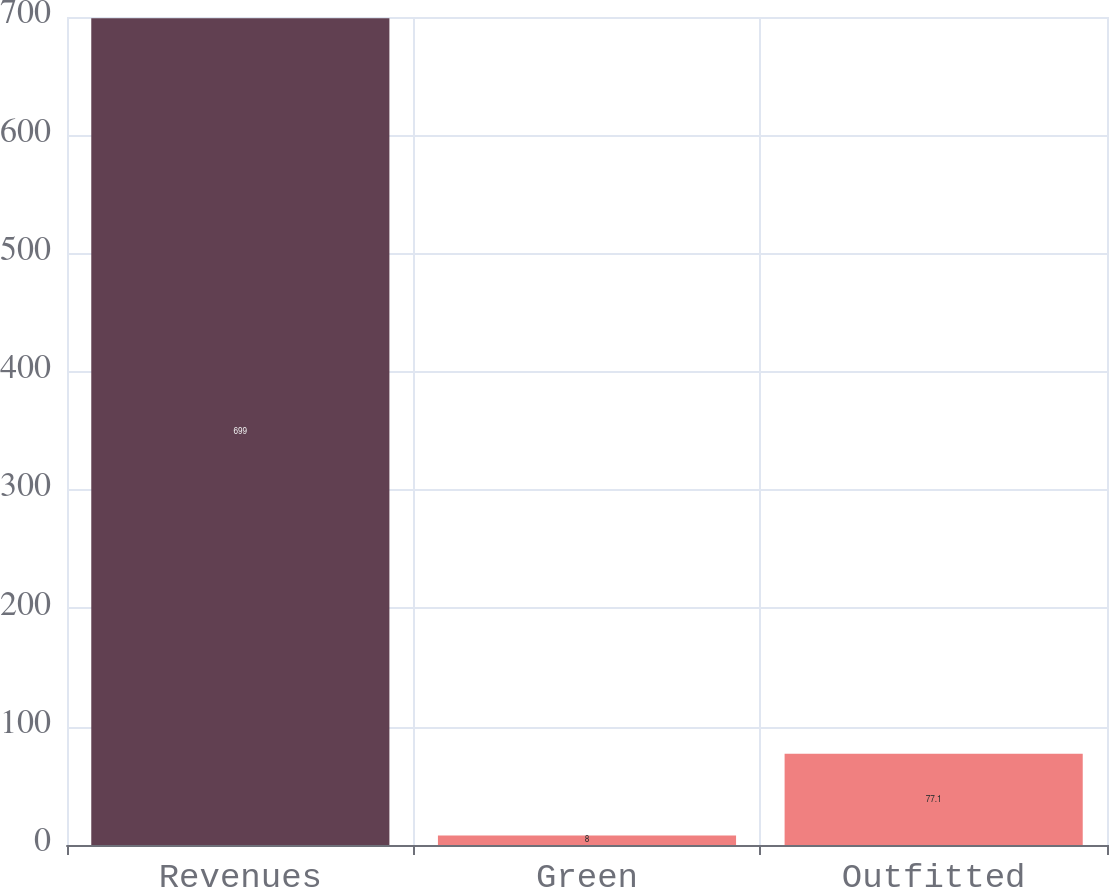Convert chart. <chart><loc_0><loc_0><loc_500><loc_500><bar_chart><fcel>Revenues<fcel>Green<fcel>Outfitted<nl><fcel>699<fcel>8<fcel>77.1<nl></chart> 